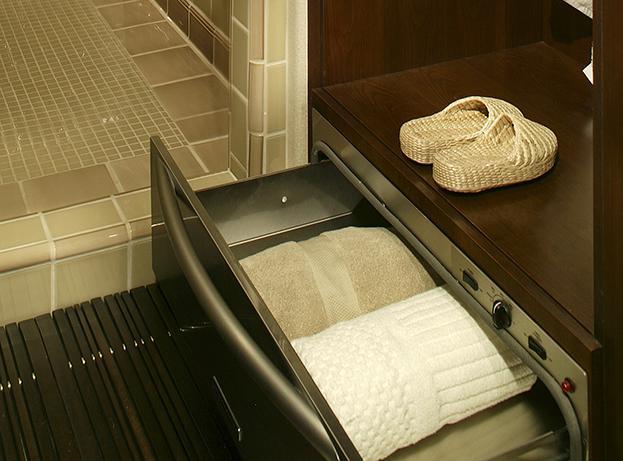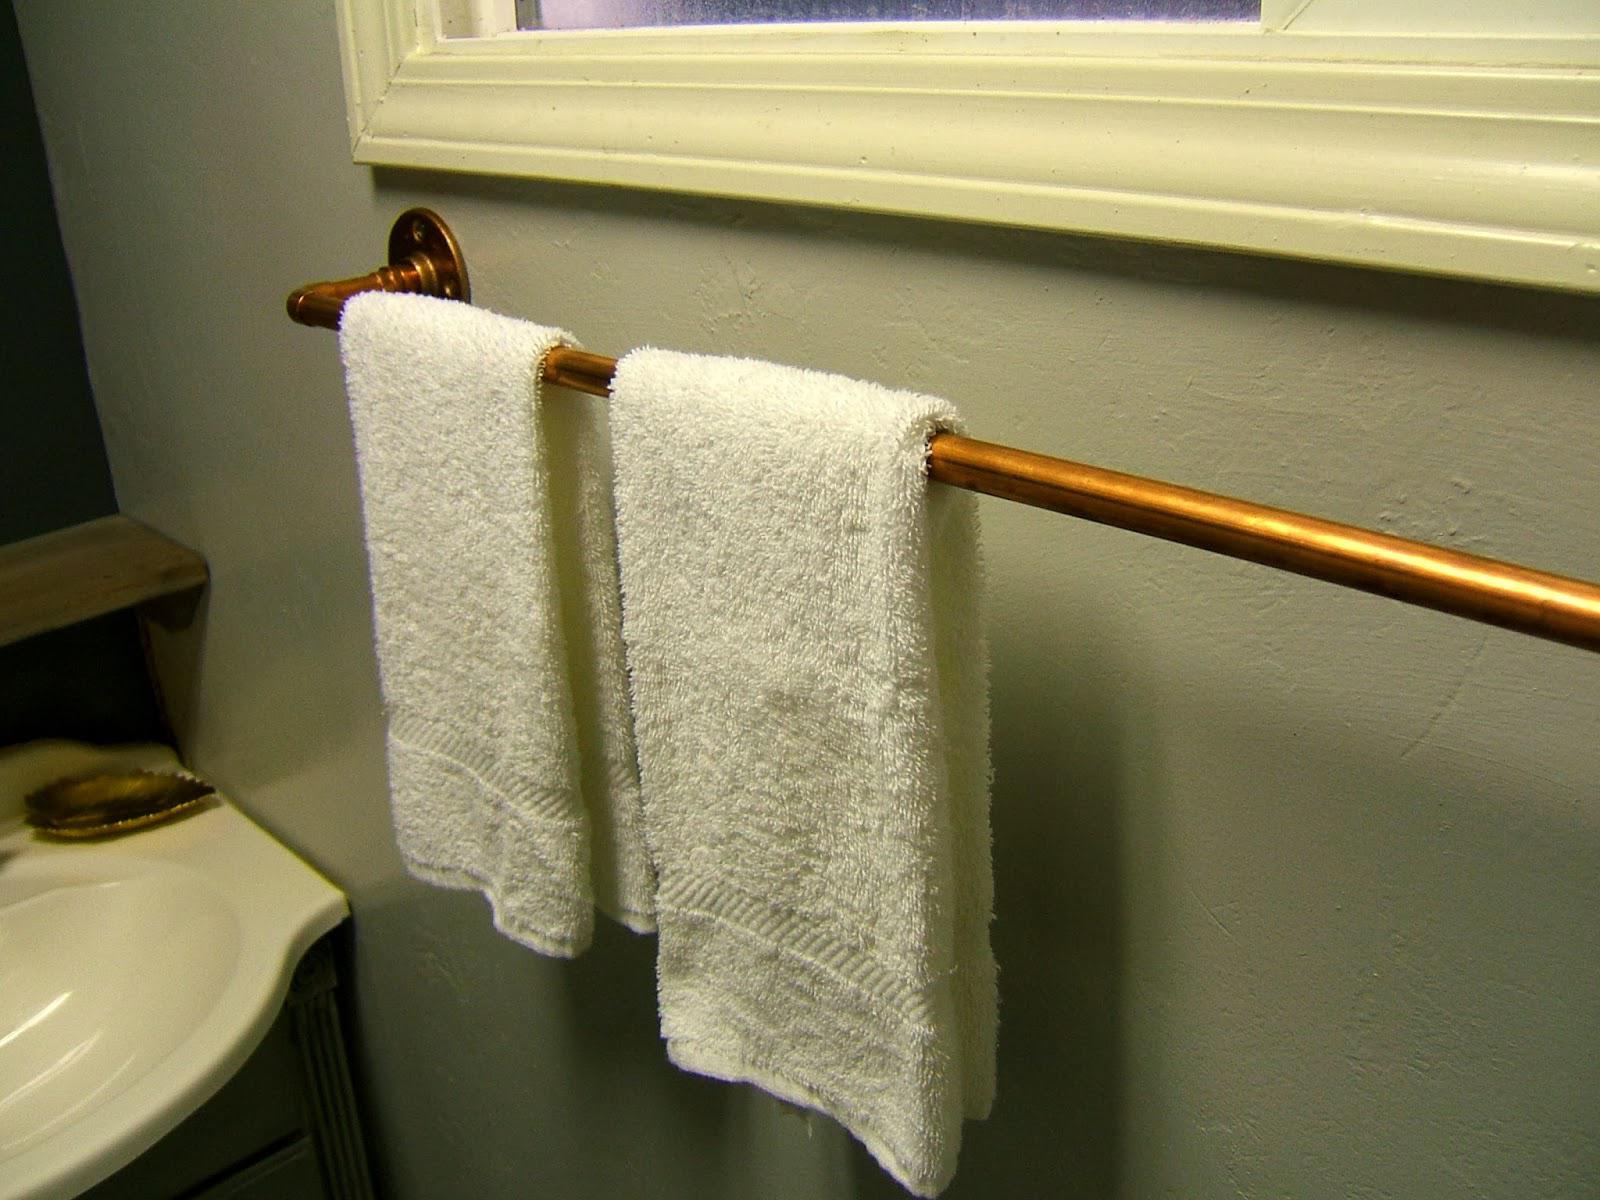The first image is the image on the left, the second image is the image on the right. Examine the images to the left and right. Is the description "The left image shows a pull-out drawer containing towels, with a long horizontal handle on the drawer." accurate? Answer yes or no. Yes. The first image is the image on the left, the second image is the image on the right. Analyze the images presented: Is the assertion "In at least one image there is an open drawer holding towels." valid? Answer yes or no. Yes. 